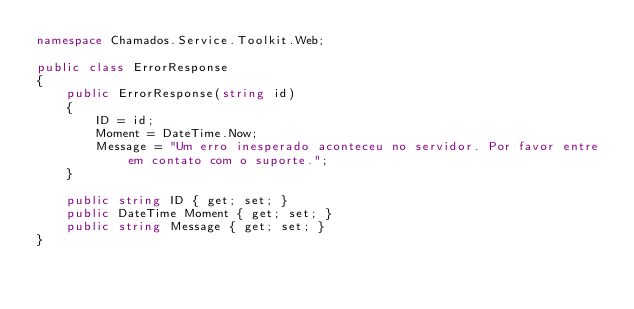Convert code to text. <code><loc_0><loc_0><loc_500><loc_500><_C#_>namespace Chamados.Service.Toolkit.Web;

public class ErrorResponse
{
    public ErrorResponse(string id)
    {
        ID = id;
        Moment = DateTime.Now;
        Message = "Um erro inesperado aconteceu no servidor. Por favor entre em contato com o suporte.";
    }

    public string ID { get; set; }
    public DateTime Moment { get; set; }
    public string Message { get; set; }
}</code> 